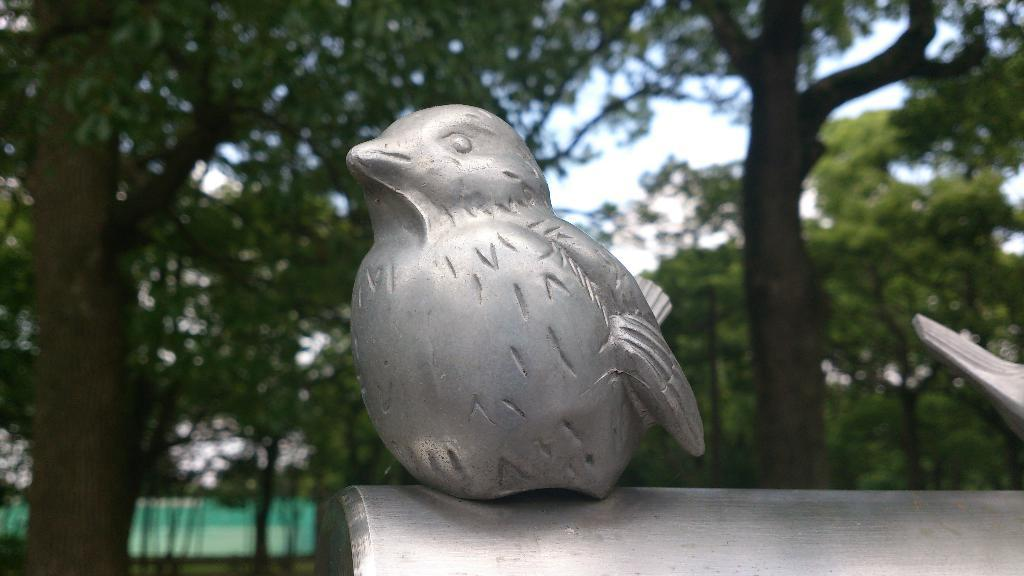What is the main subject in the foreground of the image? There is a model of a bird on a steel surface in the foreground. Are there any other models in the image? Yes, there is another model on the right side. What can be seen in the background of the image? There are trees and the sky visible in the background. How many bikes are parked near the goat in the image? There are no bikes or goats present in the image. 